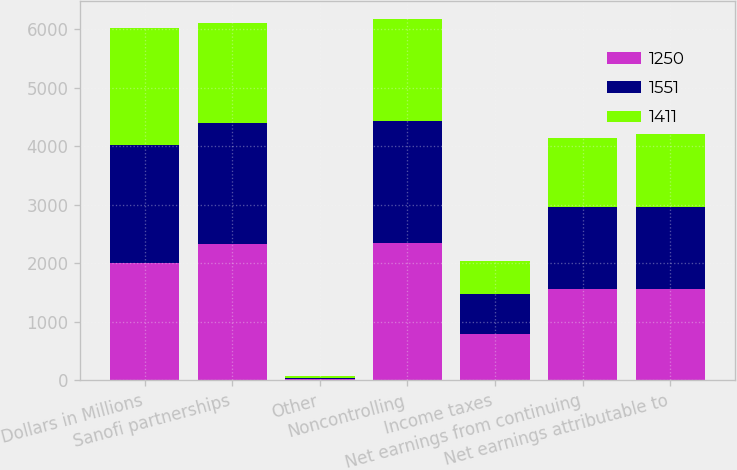Convert chart. <chart><loc_0><loc_0><loc_500><loc_500><stacked_bar_chart><ecel><fcel>Dollars in Millions<fcel>Sanofi partnerships<fcel>Other<fcel>Noncontrolling<fcel>Income taxes<fcel>Net earnings from continuing<fcel>Net earnings attributable to<nl><fcel>1250<fcel>2011<fcel>2323<fcel>20<fcel>2343<fcel>792<fcel>1551<fcel>1551<nl><fcel>1551<fcel>2010<fcel>2074<fcel>20<fcel>2094<fcel>683<fcel>1411<fcel>1411<nl><fcel>1411<fcel>2009<fcel>1717<fcel>26<fcel>1743<fcel>562<fcel>1181<fcel>1250<nl></chart> 